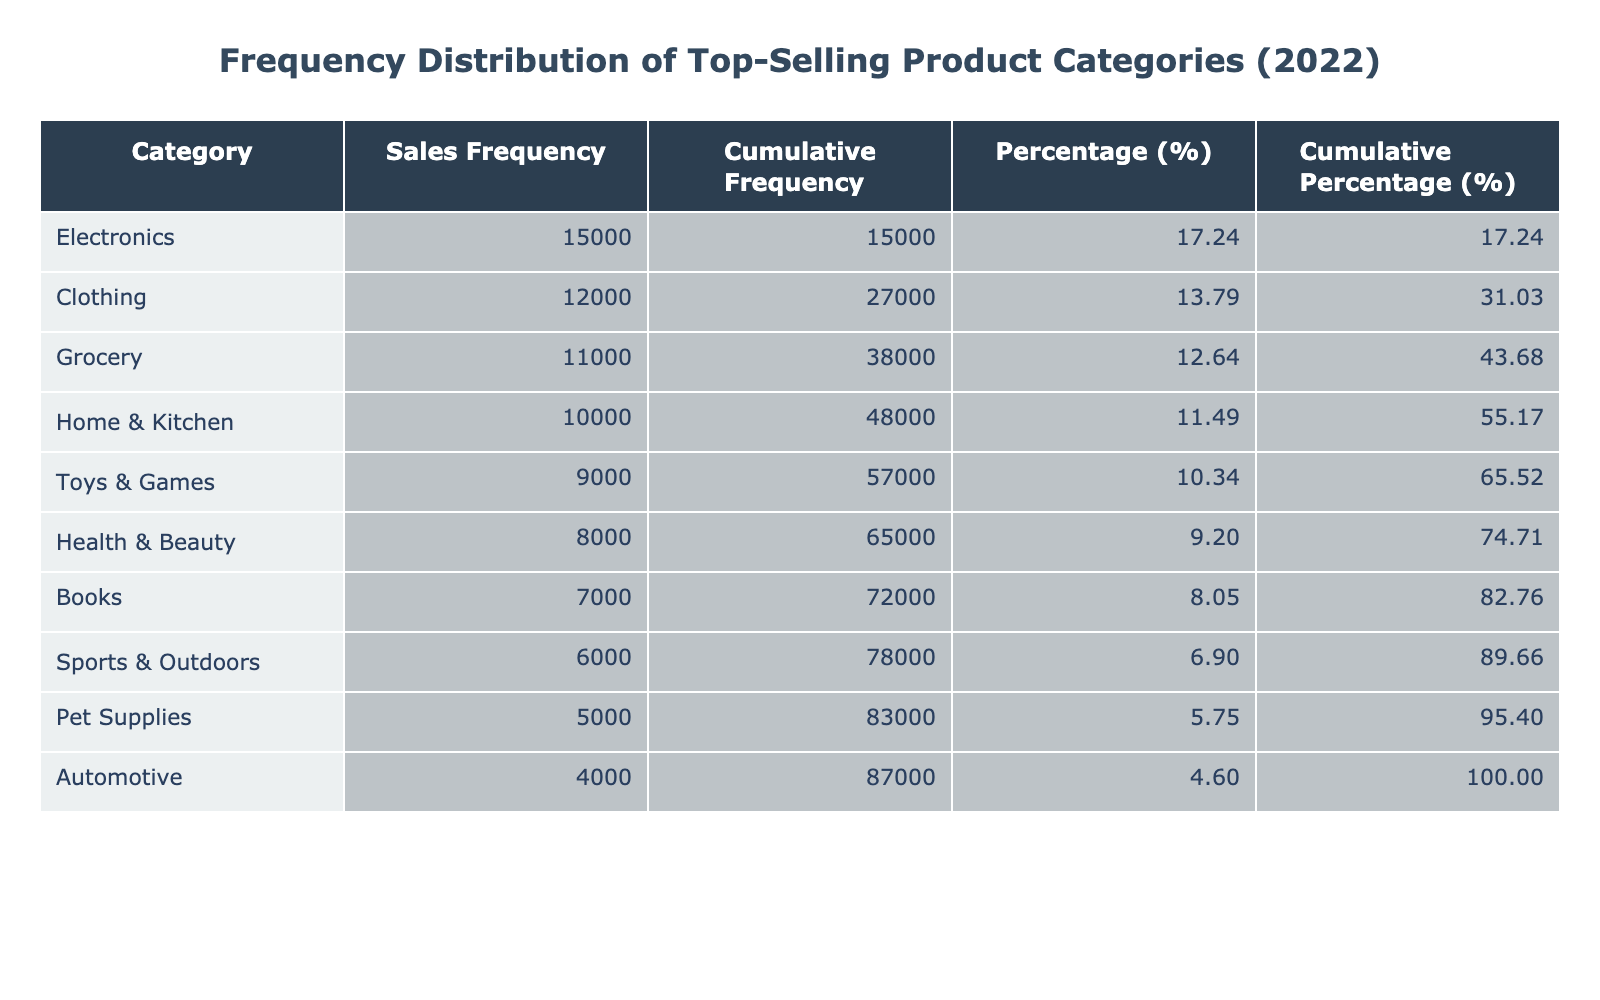What is the sales frequency for the Electronics category? The sales frequency for the Electronics category is directly listed in the table. Looking at the relevant row, we can see the value is 15000.
Answer: 15000 Which product category has the lowest sales frequency? By examining the table, we can see all categories listed alongside their sales frequencies. The category with the lowest sales frequency is Automotive, with a value of 4000.
Answer: Automotive What category has a sales frequency above 10000? We can filter the table to find categories that exceed the value of 10000. The categories that qualify are Electronics, Clothing, and Grocery with sales frequencies of 15000, 12000, and 11000, respectively.
Answer: Electronics, Clothing, Grocery How much more selling frequency does Clothing have than Sports & Outdoors? To find the difference in sales frequency between Clothing and Sports & Outdoors, we look at the sales frequency for each: Clothing has 12000 and Sports & Outdoors has 6000. Therefore, the difference is 12000 - 6000 = 6000.
Answer: 6000 Is the cumulative percentage for Health & Beauty category more than 20%? First, we find the cumulative percentage for the Health & Beauty category in the table, which is calculated by summing up its percentage with previous categories. The cumulative percentage for Health & Beauty is 31.71%, which is greater than 20%. Hence, the statement is true.
Answer: Yes What is the combined sales frequency of Toys & Games and Pet Supplies? We will sum the sales frequencies of both categories. The sales frequency for Toys & Games is 9000 and for Pet Supplies is 5000. Therefore, the combined total is 9000 + 5000 = 14000.
Answer: 14000 Which category contributes to the highest cumulative frequency? By checking the cumulative frequencies presented in the table, we observe that the Electronics category has the highest cumulative frequency of 15000, leading all categories in total sales frequency.
Answer: Electronics Does the Grocery category have a cumulative frequency less than 30000? To determine this, we check the cumulative frequency for the Grocery category, which, when added with other preceding categories, yields a value of less than 30000. Thus, we can conclude that this statement is true.
Answer: Yes What is the average sales frequency for the top three product categories? First, identify the top three categories by sales frequency: Electronics (15000), Clothing (12000), and Grocery (11000). Next, we sum these values: 15000 + 12000 + 11000 = 38000, and then divide by the number of categories (3), which gives us an average of 38000 / 3 = 12666.67.
Answer: 12666.67 